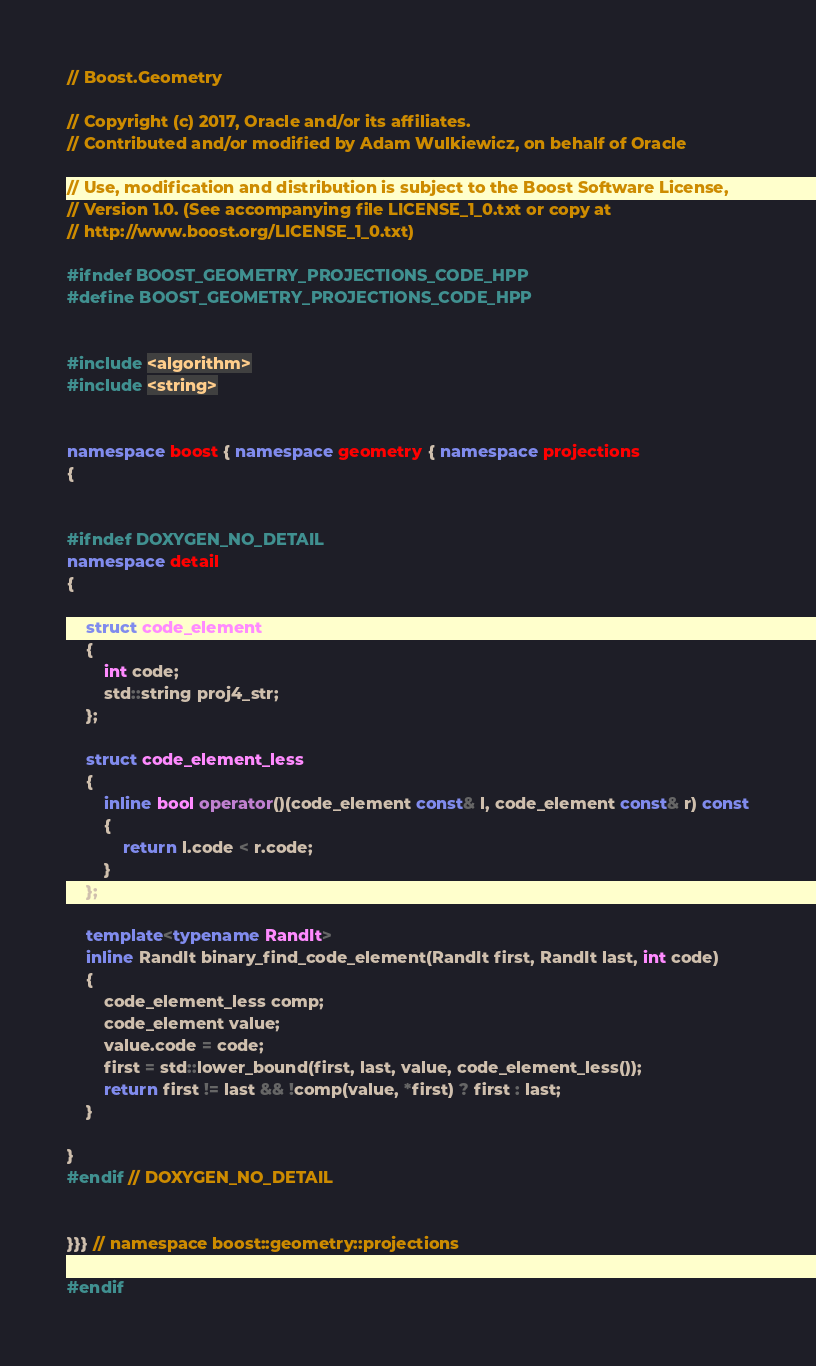<code> <loc_0><loc_0><loc_500><loc_500><_C++_>// Boost.Geometry

// Copyright (c) 2017, Oracle and/or its affiliates.
// Contributed and/or modified by Adam Wulkiewicz, on behalf of Oracle

// Use, modification and distribution is subject to the Boost Software License,
// Version 1.0. (See accompanying file LICENSE_1_0.txt or copy at
// http://www.boost.org/LICENSE_1_0.txt)

#ifndef BOOST_GEOMETRY_PROJECTIONS_CODE_HPP
#define BOOST_GEOMETRY_PROJECTIONS_CODE_HPP


#include <algorithm>
#include <string>


namespace boost { namespace geometry { namespace projections
{


#ifndef DOXYGEN_NO_DETAIL
namespace detail
{

    struct code_element
    {
        int code;
        std::string proj4_str;
    };

    struct code_element_less
    {
        inline bool operator()(code_element const& l, code_element const& r) const
        {
            return l.code < r.code;
        }
    };

    template<typename RandIt>
    inline RandIt binary_find_code_element(RandIt first, RandIt last, int code)
    {
        code_element_less comp;
        code_element value;
        value.code = code;
        first = std::lower_bound(first, last, value, code_element_less());
        return first != last && !comp(value, *first) ? first : last;
    }

}
#endif // DOXYGEN_NO_DETAIL


}}} // namespace boost::geometry::projections

#endif
</code> 